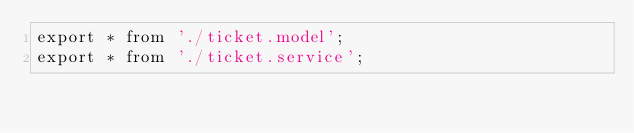<code> <loc_0><loc_0><loc_500><loc_500><_TypeScript_>export * from './ticket.model';
export * from './ticket.service';</code> 